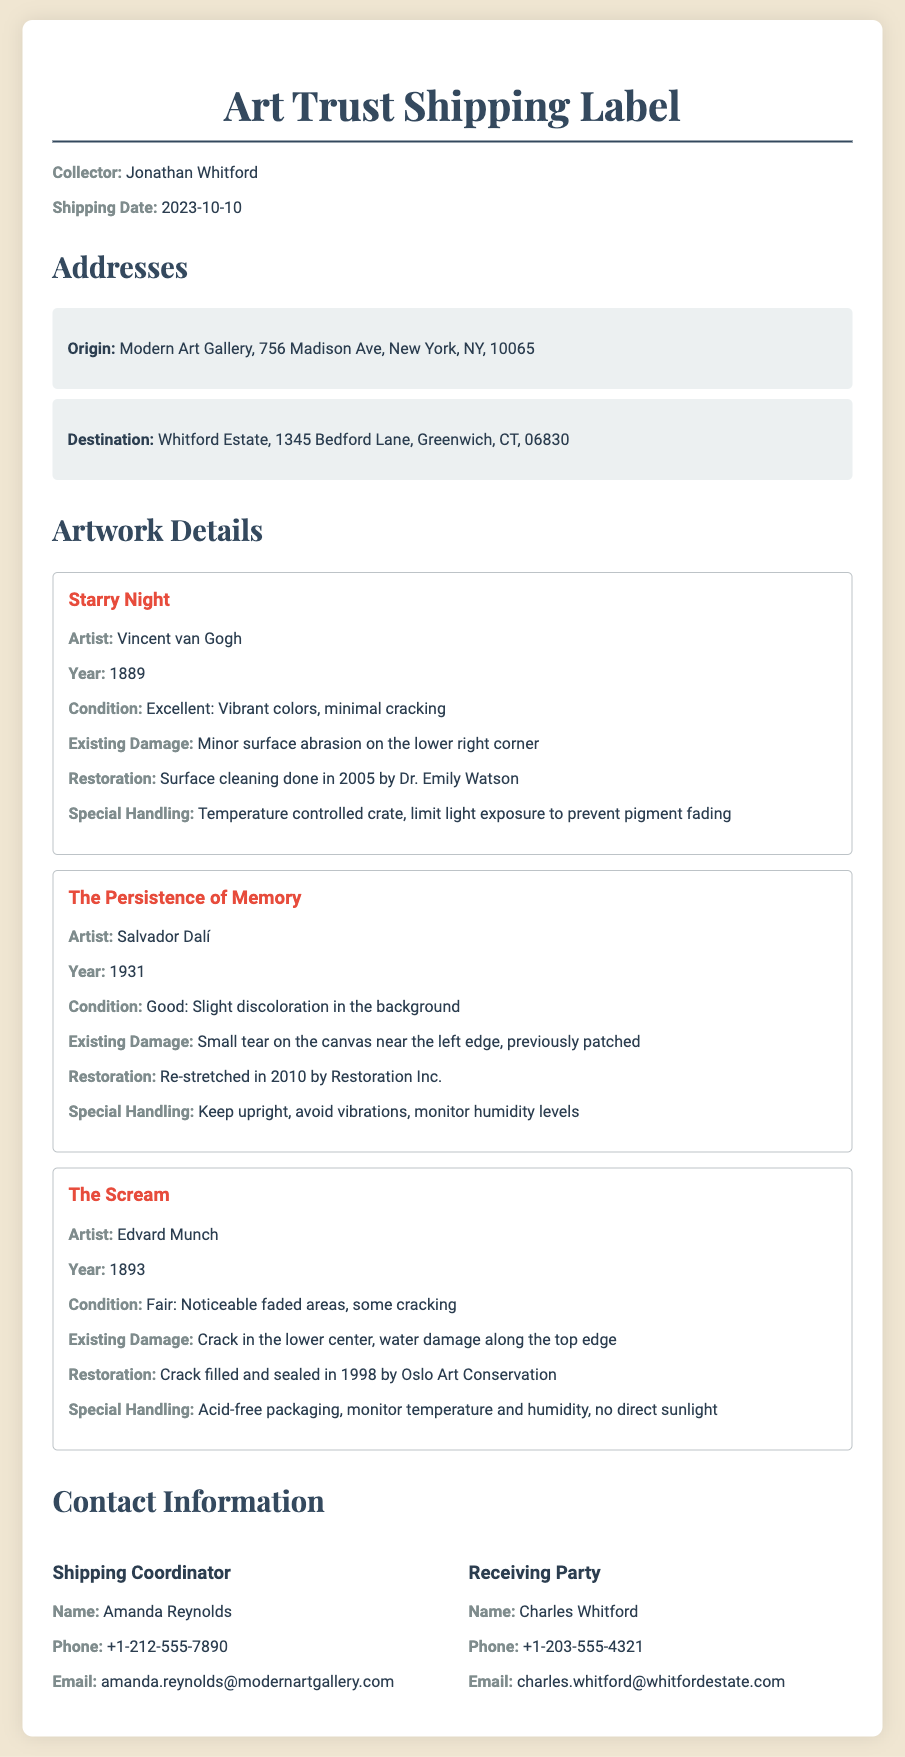What is the name of the collector? The collector's name is listed at the top of the document under "Collector."
Answer: Jonathan Whitford When was the artwork shipped? The shipping date is provided in the document, noted as "Shipping Date."
Answer: 2023-10-10 What is the condition of "Starry Night"? The condition of "Starry Night" is mentioned directly in the artwork details section.
Answer: Excellent What special handling instructions are provided for "The Scream"? Special handling instructions are outlined in the description of "The Scream."
Answer: Acid-free packaging, monitor temperature and humidity, no direct sunlight Which artist created "The Persistence of Memory"? The artist's name is specified in the details of the artwork.
Answer: Salvador Dalí How many artworks are mentioned in the document? The number of artworks is determined by counting the pieces listed under "Artwork Details."
Answer: Three What existing damage is noted for "The Scream"? Existing damage is described specifically in the condition report for "The Scream."
Answer: Crack in the lower center, water damage along the top edge What is the email of the Shipping Coordinator? The email address for the Shipping Coordinator is supplied in the contact information section.
Answer: amanda.reynolds@modernartgallery.com What year was "The Persistence of Memory" created? The creation year is directly provided in the details of the artwork.
Answer: 1931 